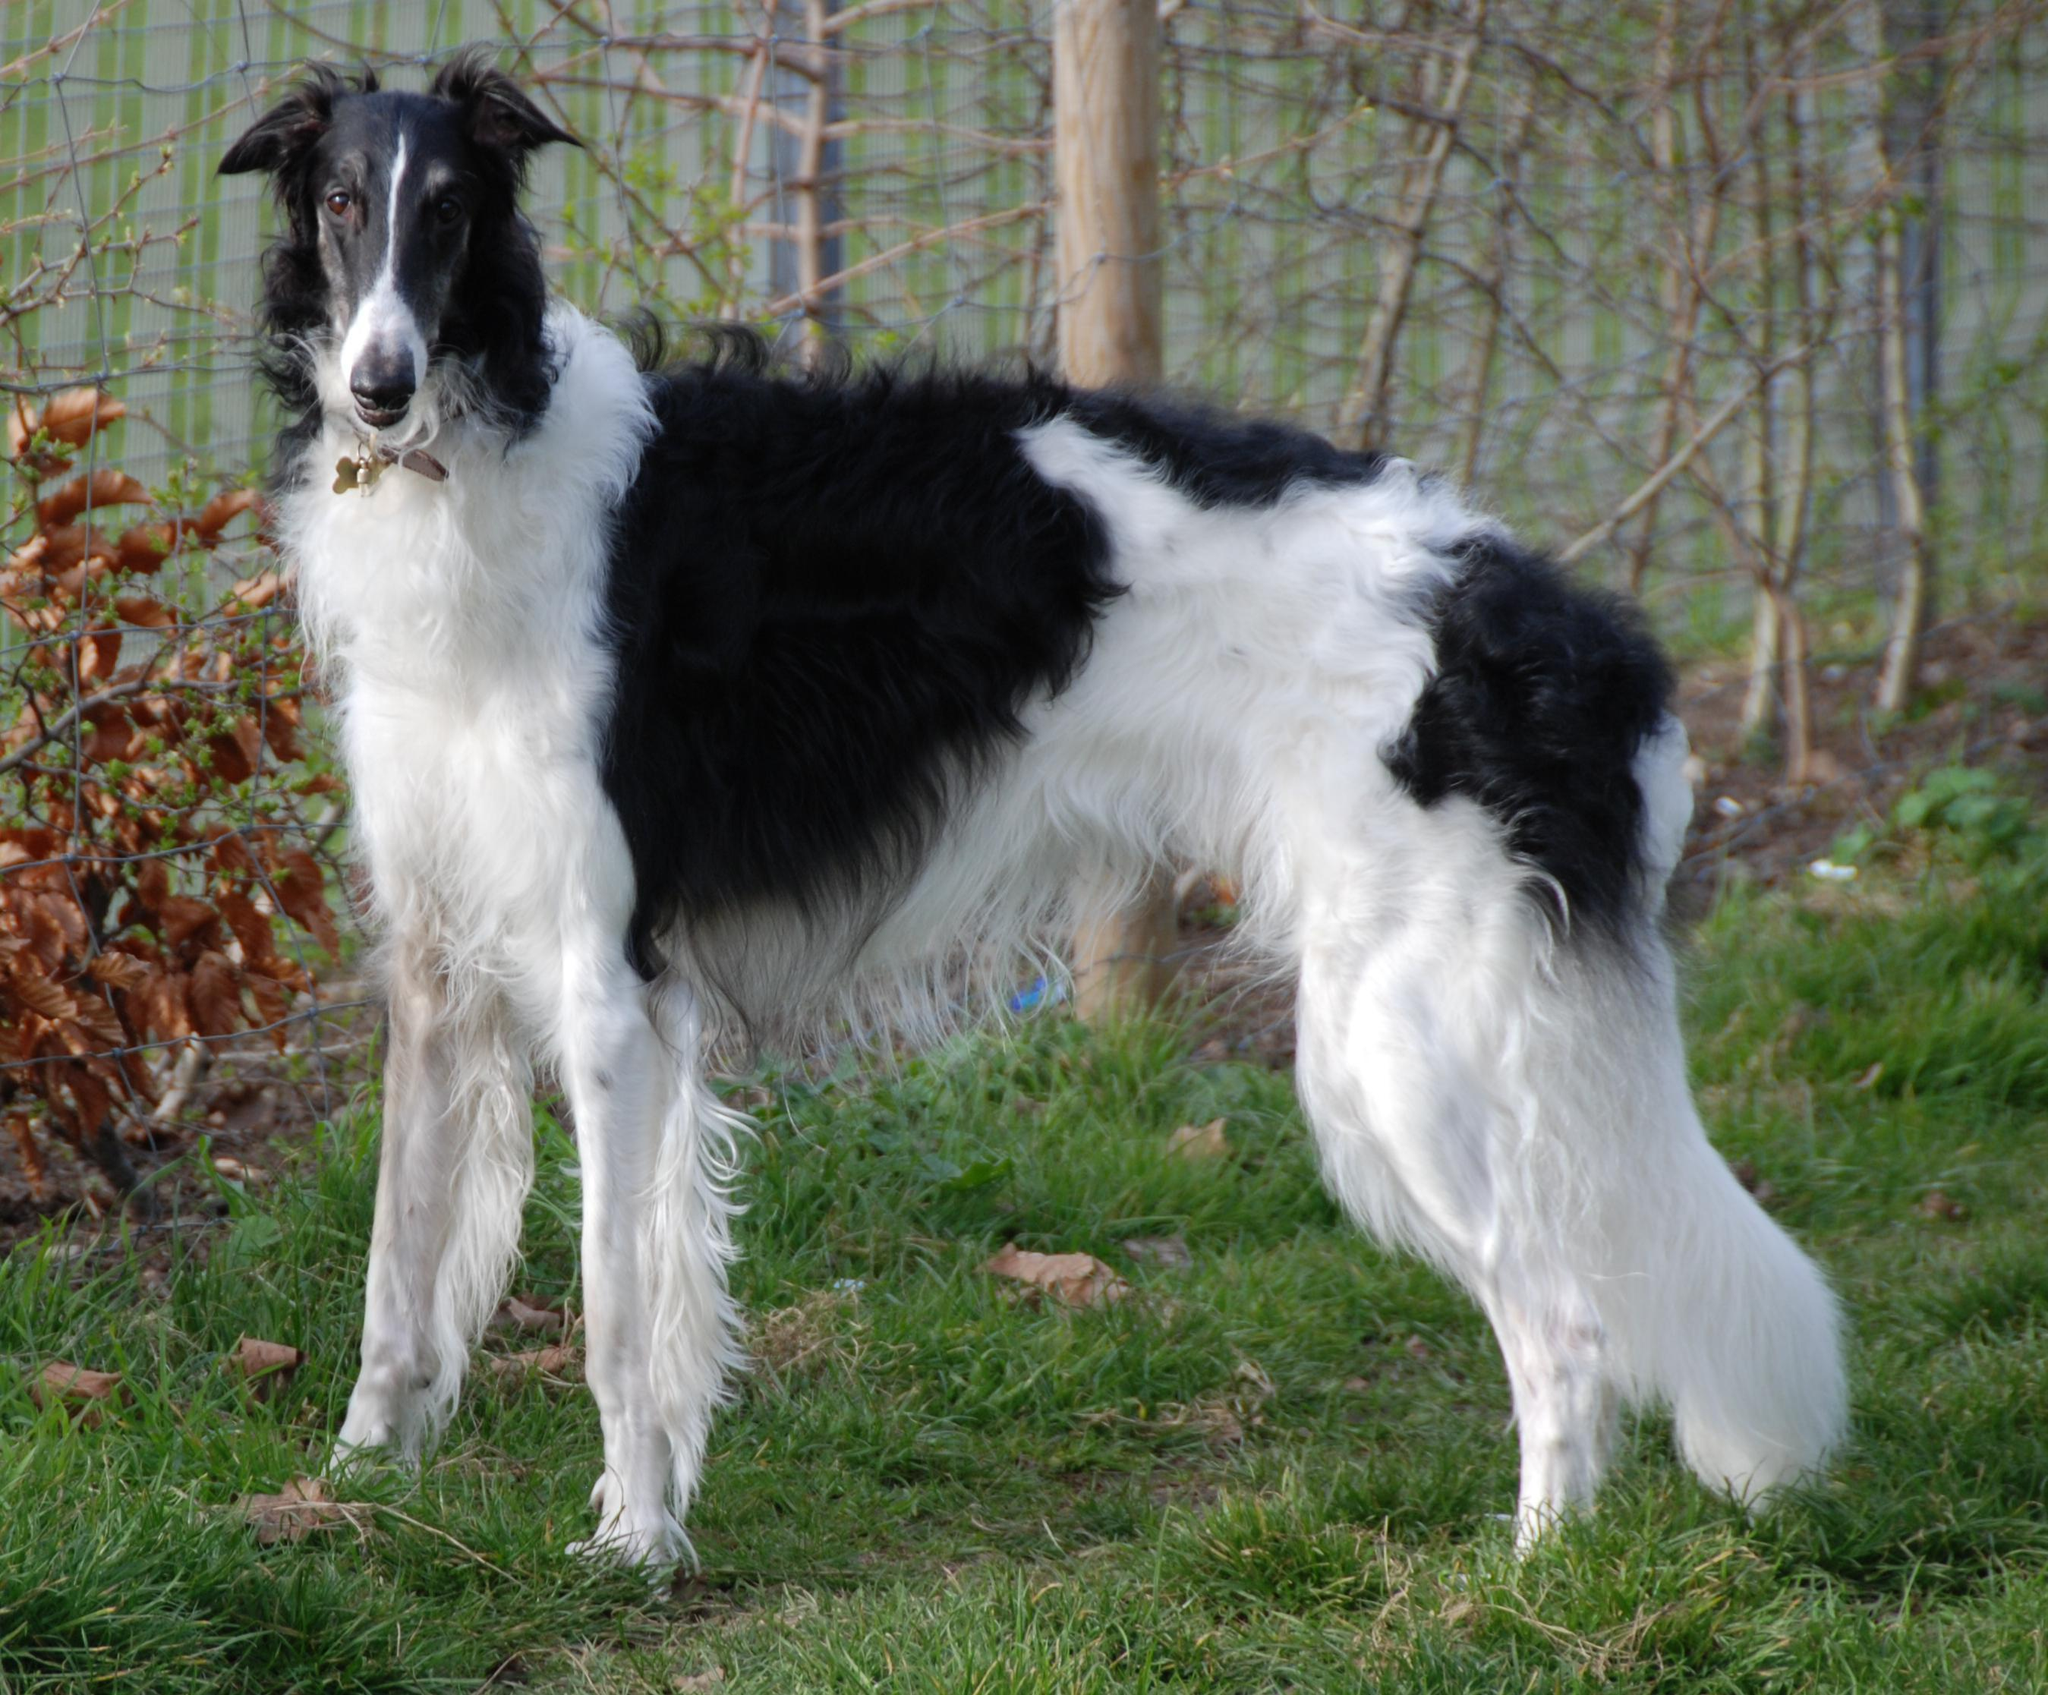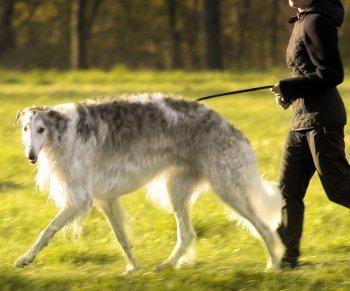The first image is the image on the left, the second image is the image on the right. Analyze the images presented: Is the assertion "There is one dog in one of the images, and four or more dogs in the other image." valid? Answer yes or no. No. The first image is the image on the left, the second image is the image on the right. For the images shown, is this caption "A person is standing with the dog in the image on the right." true? Answer yes or no. Yes. 